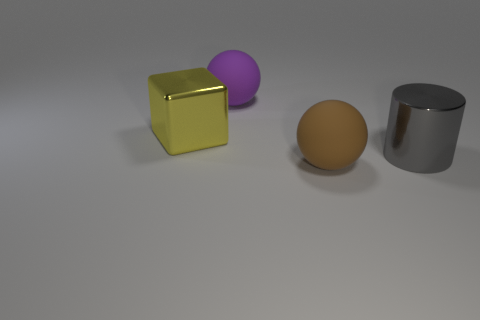How many matte objects are big blocks or red objects?
Your answer should be compact. 0. Is the number of brown objects on the left side of the large yellow object less than the number of things on the left side of the large brown rubber sphere?
Ensure brevity in your answer.  Yes. How many things are large yellow metal things or objects that are to the left of the big purple matte ball?
Give a very brief answer. 1. There is a yellow thing that is the same size as the cylinder; what is its material?
Ensure brevity in your answer.  Metal. Is the gray cylinder made of the same material as the big yellow cube?
Your answer should be compact. Yes. The large thing that is both left of the large brown rubber ball and in front of the big purple sphere is what color?
Provide a succinct answer. Yellow. The purple thing that is the same size as the gray metal cylinder is what shape?
Provide a succinct answer. Sphere. What number of other things are the same color as the metal cylinder?
Keep it short and to the point. 0. What number of other objects are there of the same material as the yellow cube?
Your answer should be compact. 1. What color is the big cylinder?
Make the answer very short. Gray. 